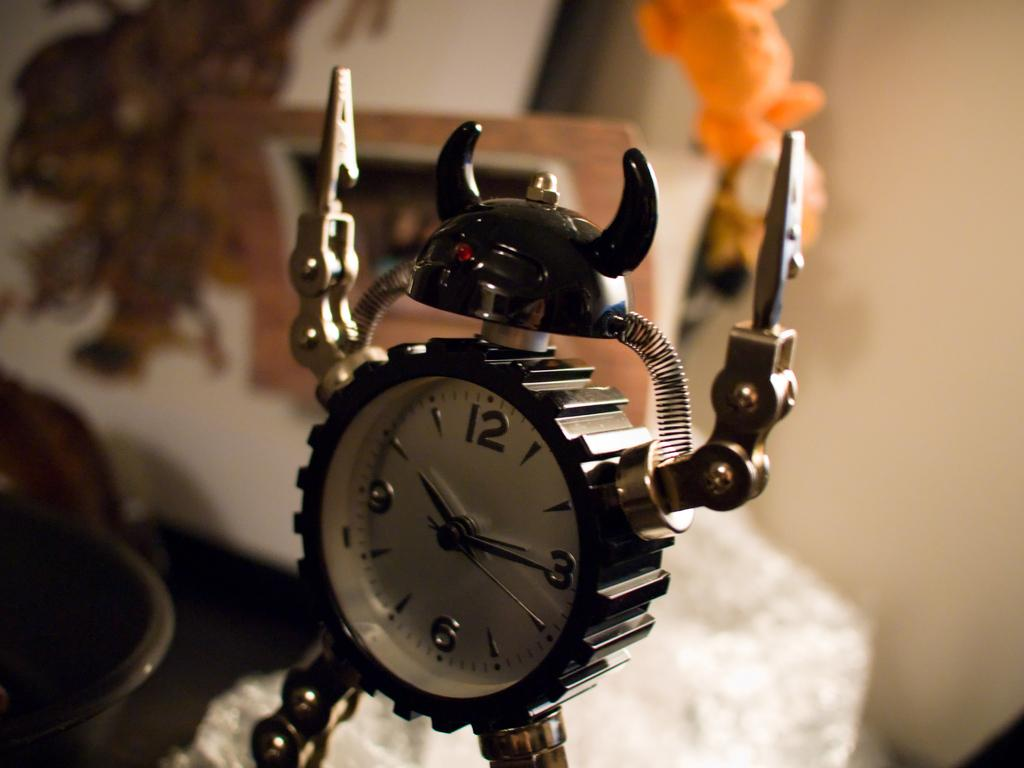Provide a one-sentence caption for the provided image. An alarm clock at 10:16 shaped like a warrior. 